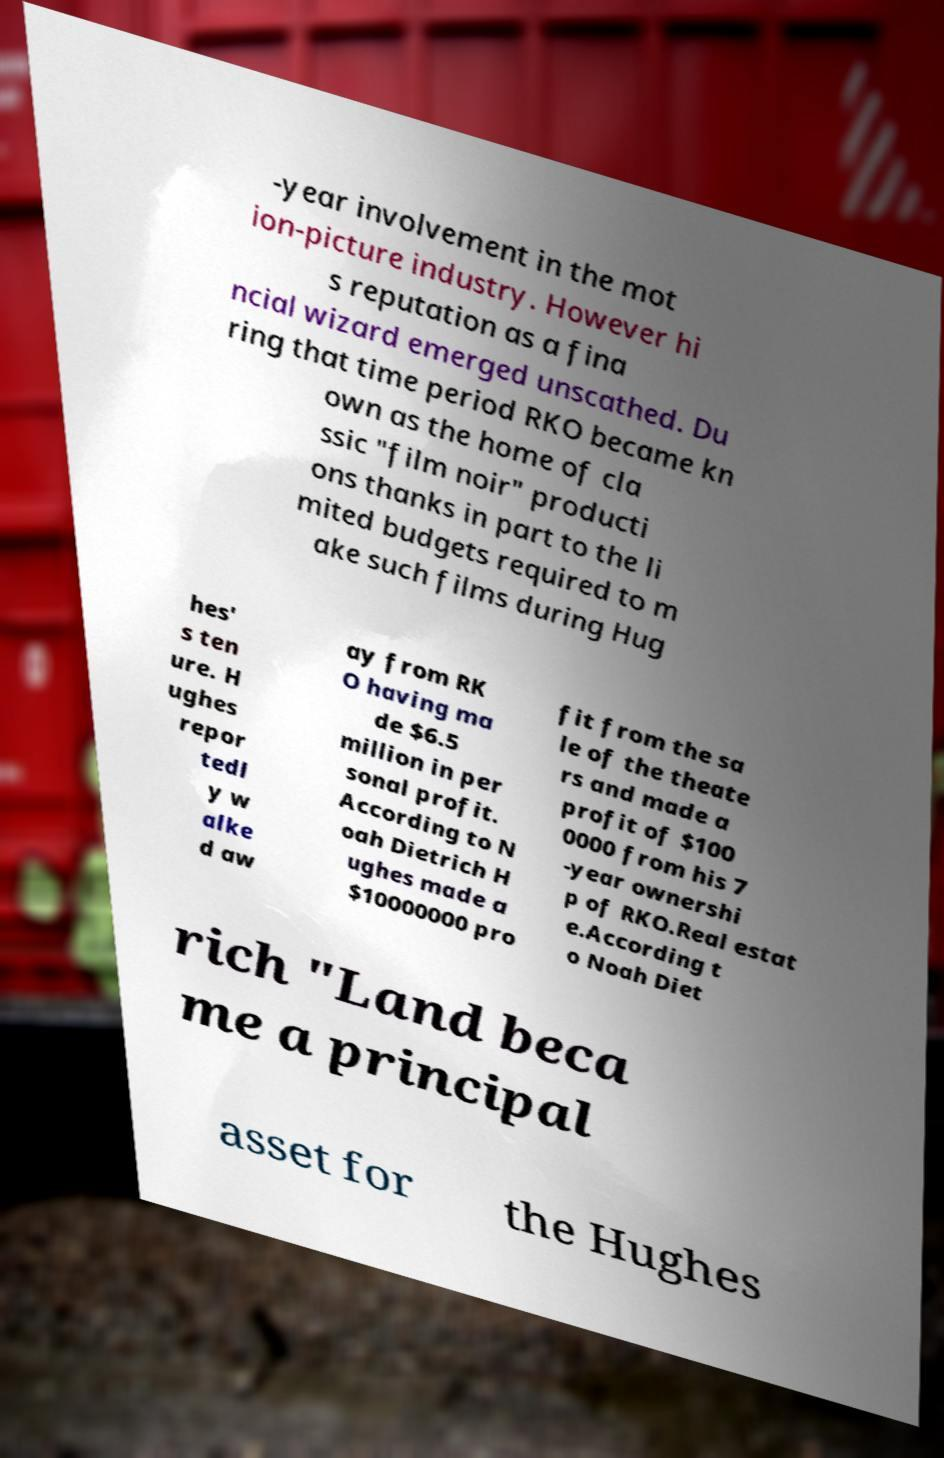There's text embedded in this image that I need extracted. Can you transcribe it verbatim? -year involvement in the mot ion-picture industry. However hi s reputation as a fina ncial wizard emerged unscathed. Du ring that time period RKO became kn own as the home of cla ssic "film noir" producti ons thanks in part to the li mited budgets required to m ake such films during Hug hes' s ten ure. H ughes repor tedl y w alke d aw ay from RK O having ma de $6.5 million in per sonal profit. According to N oah Dietrich H ughes made a $10000000 pro fit from the sa le of the theate rs and made a profit of $100 0000 from his 7 -year ownershi p of RKO.Real estat e.According t o Noah Diet rich "Land beca me a principal asset for the Hughes 